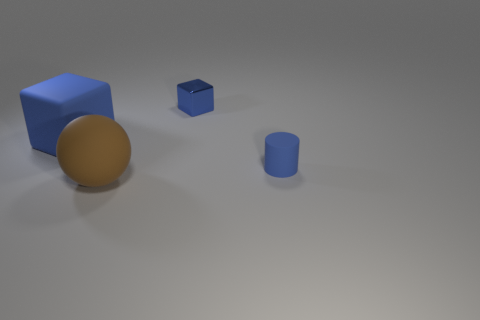Do the blue shiny block and the blue matte cylinder have the same size?
Your answer should be compact. Yes. The small thing behind the rubber block is what color?
Provide a short and direct response. Blue. Are there any small matte cylinders of the same color as the big cube?
Provide a succinct answer. Yes. There is a metallic cube that is the same size as the matte cylinder; what is its color?
Make the answer very short. Blue. Is the shape of the brown matte thing the same as the tiny shiny object?
Provide a short and direct response. No. What is the small blue cylinder on the right side of the matte block made of?
Your answer should be compact. Rubber. What color is the small metal cube?
Offer a very short reply. Blue. Is the size of the object that is behind the big rubber cube the same as the blue cube to the left of the big brown thing?
Your answer should be very brief. No. How big is the blue object that is both on the right side of the big blue rubber block and in front of the small metal thing?
Make the answer very short. Small. What is the color of the other big thing that is the same shape as the blue shiny thing?
Ensure brevity in your answer.  Blue. 